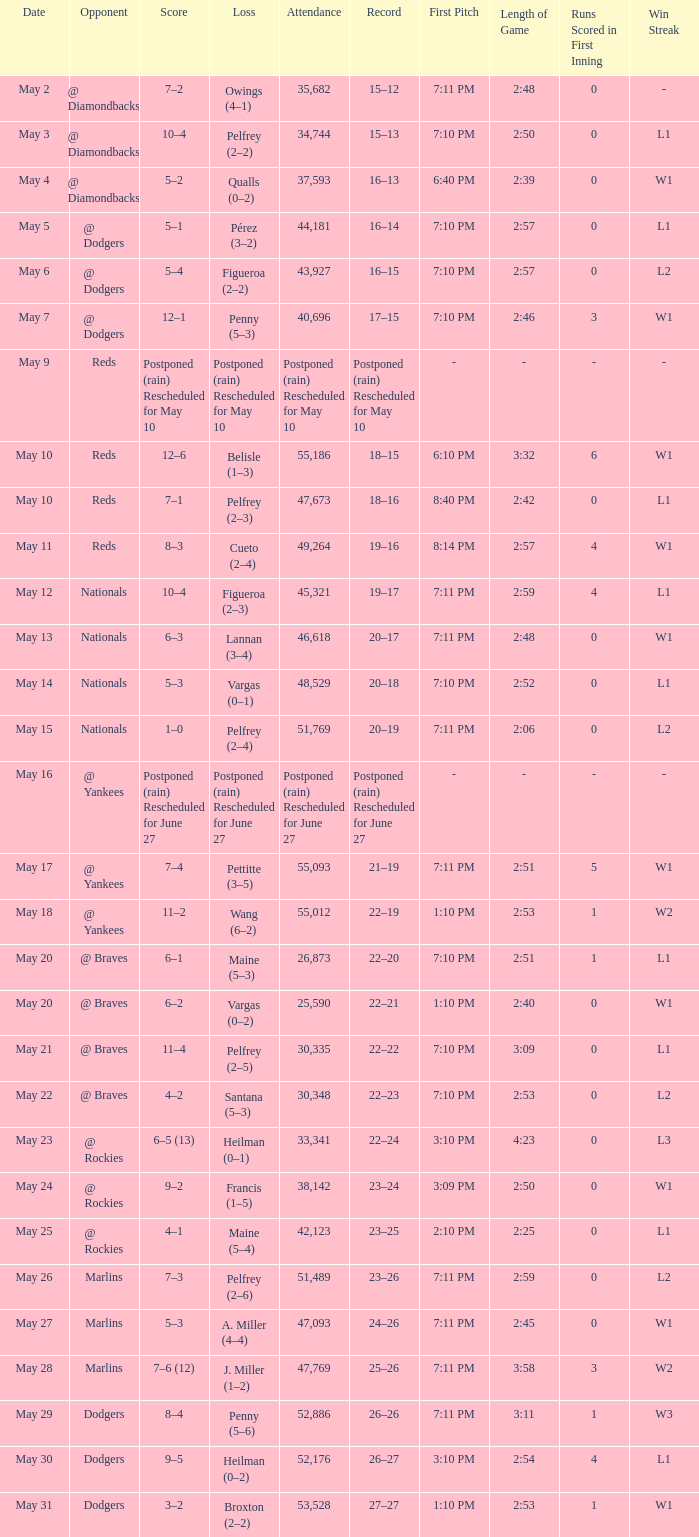Score of postponed (rain) rescheduled for June 27 had what loss? Postponed (rain) Rescheduled for June 27. 